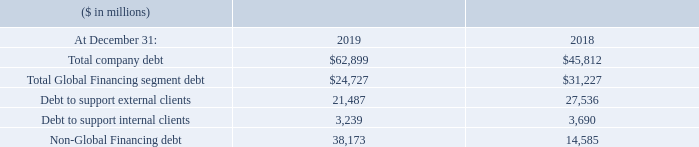Debt
Our funding requirements are continually monitored and we execute our strategies to manage the overall asset and liability profile. Additionally, we maintain sufficient flexibility to access global funding sources as needed.
Total debt of $62,899 million increased $17,087 million from December 31, 2018, driven by issuances of $32,415 million; partially offset by debt maturities of $12,673 million and a decrease in commercial paper of $2,691 million.
Non-Global Financing debt of $38,173 million increased $23,587 million from prior year-end levels primarily driven by issuances to fund the Red Hat acquisition.
Global Financing debt of $24,727 million decreased $6,500 million from December 31, 2018, primarily due to the wind down of OEM IT commercial financing operations.
Global Financing provides financing predominantly for IBM’s external client assets, as well as for assets under contract by other IBM units. These assets, primarily for GTS, generate long-term, stable revenue streams similar to the Global Financing asset portfolio. Based on their attributes, these GTS assets are leveraged with the balance of the Global Financing asset base.
The debt used to fund Global Financing assets is composed of intercompany loans and external debt. Total debt changes generally correspond with the level of client and commercial financing receivables, the level of cash and cash equivalents, the change in intercompany and external payables and the change in intercompany investment from IBM. The terms of the intercompany loans are set by the company to substantially match the term, currency and interest rate variability underlying the financing receivable and are based on arm’s-length pricing. The Global Financing debt-to-equity ratio remained at 9 to 1 at December 31, 2019.
As previously stated, we measure Global Financing as a stand-alone entity, and accordingly, interest expense relating to debt supporting Global Financing’s external client and internal business is included in the “Global Financing Results of Operations” and in note D, “Segments.” In the Consolidated Income Statement, the external debt-related interest expense supporting Global Financing’s internal financing to IBM is reclassified from cost of financing to interest expense.
What caused the decrease in the total debt? Driven by issuances of $32,415 million; partially offset by debt maturities of $12,673 million and a decrease in commercial paper of $2,691 million. What was the increase in the Non-Global Financing debt from 2018? $23,587 million. What was the increase in the Global Financing debt from 2018? $6,500 million. What was the increase / (decrease) in the total company debt from 2018 to 2019?
Answer scale should be: million. 62,899 - 45,812
Answer: 17087. What was the average Debt to support external clients?
Answer scale should be: million. (21,487 + 27,536) / 2
Answer: 24511.5. What is the percentage increase / (decrease) in the Non-Global Financing debt from 2018 to 2019?
Answer scale should be: percent. 38,173 / 14,585 - 1
Answer: 161.73. 